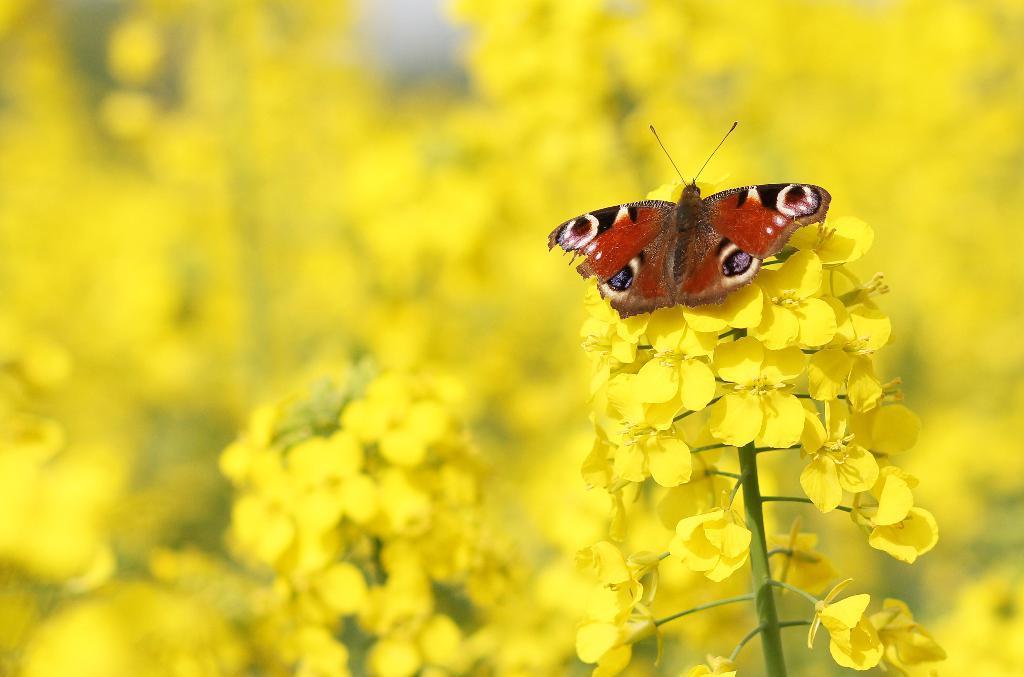Please provide a concise description of this image. In this image I can see the butterfly which is in brown, white, black and purple color. It is on the yellow color flowers. I can see few more yellow color flowers in the back and the background is blurred. 